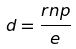<formula> <loc_0><loc_0><loc_500><loc_500>d = \frac { r n p } { e }</formula> 